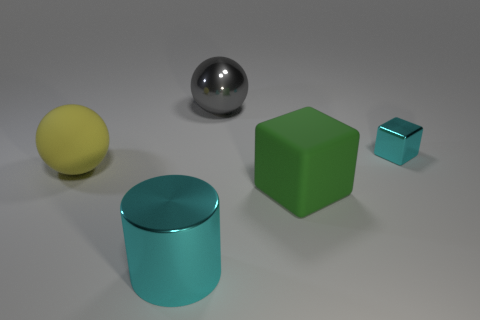Add 4 green blocks. How many objects exist? 9 Subtract all cylinders. How many objects are left? 4 Add 1 big gray things. How many big gray things exist? 2 Subtract 0 red blocks. How many objects are left? 5 Subtract all tiny cyan things. Subtract all large matte cubes. How many objects are left? 3 Add 2 green things. How many green things are left? 3 